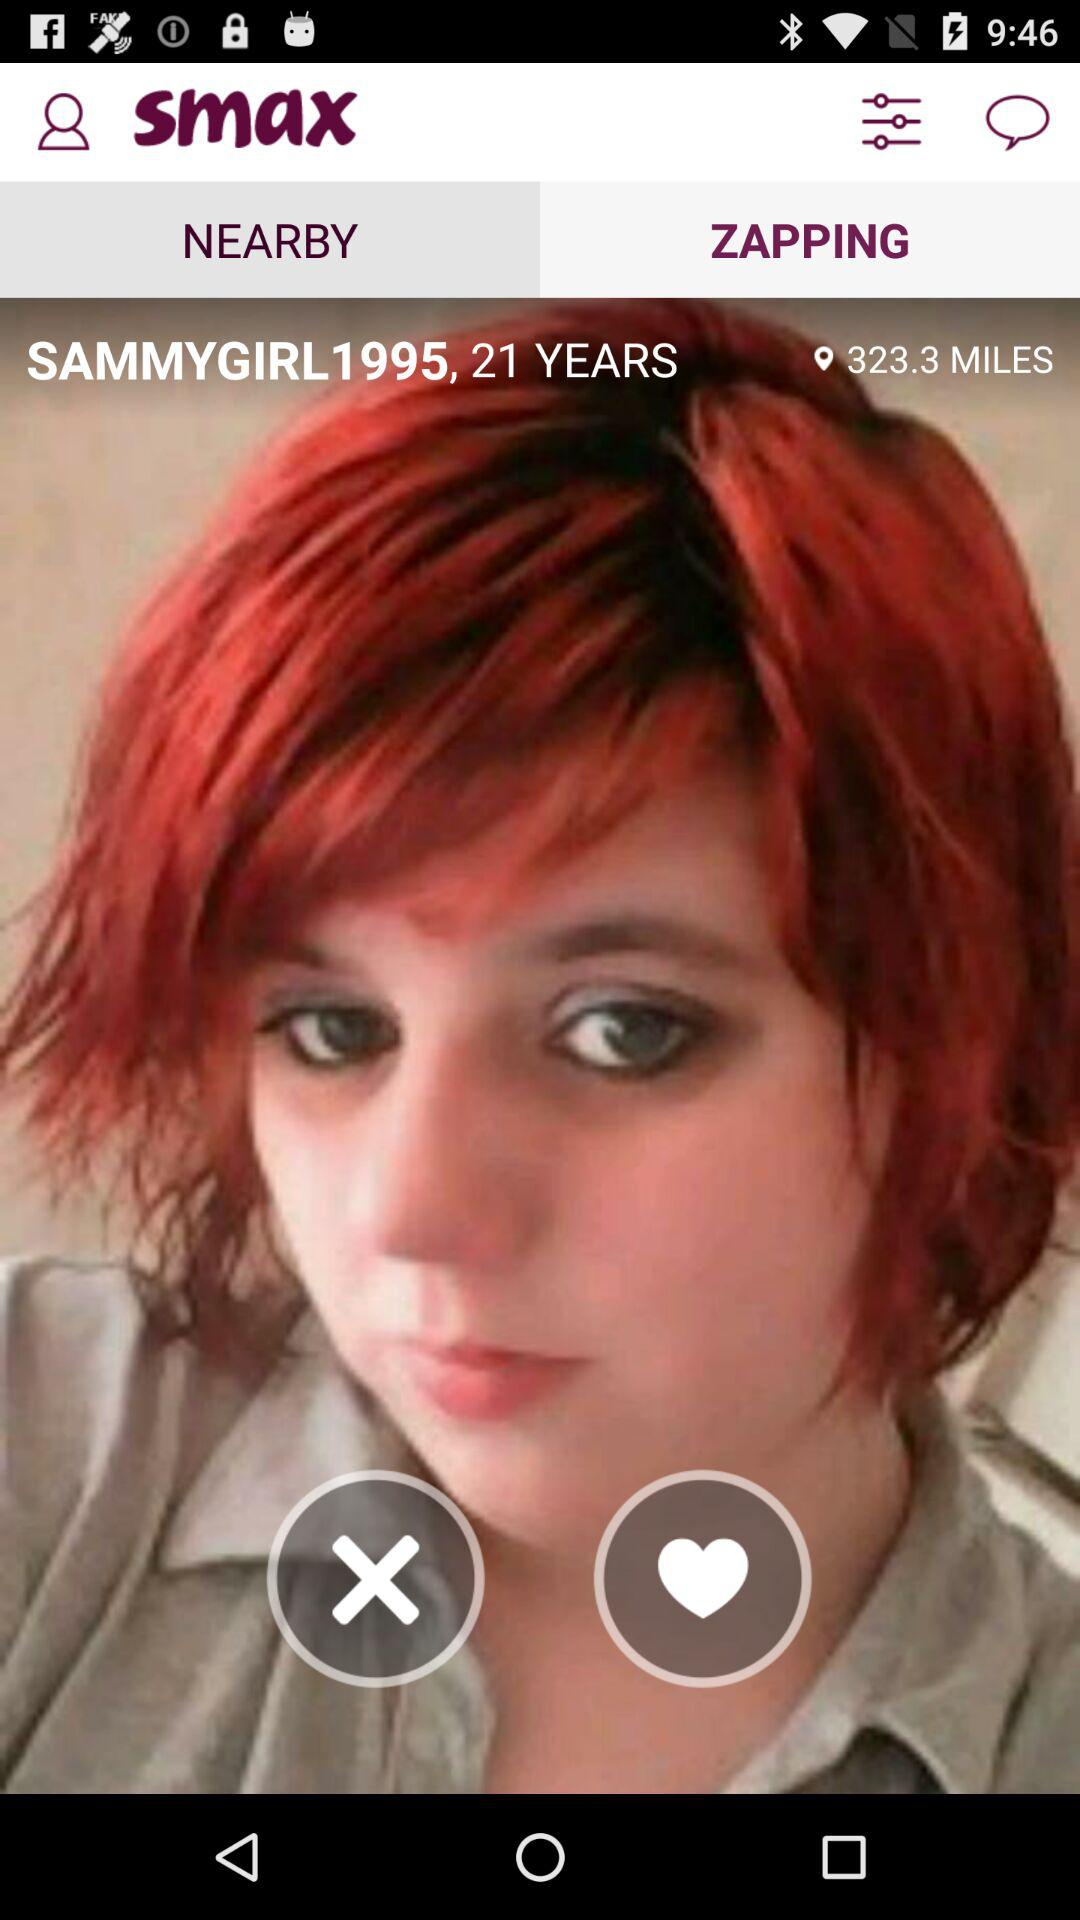How old is "SAMMYGIRL1995"? "SAMMYGIRL1995" is 21 years old. 